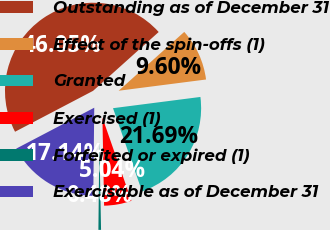Convert chart. <chart><loc_0><loc_0><loc_500><loc_500><pie_chart><fcel>Outstanding as of December 31<fcel>Effect of the spin-offs (1)<fcel>Granted<fcel>Exercised (1)<fcel>Forfeited or expired (1)<fcel>Exercisable as of December 31<nl><fcel>46.05%<fcel>9.6%<fcel>21.69%<fcel>5.04%<fcel>0.48%<fcel>17.14%<nl></chart> 